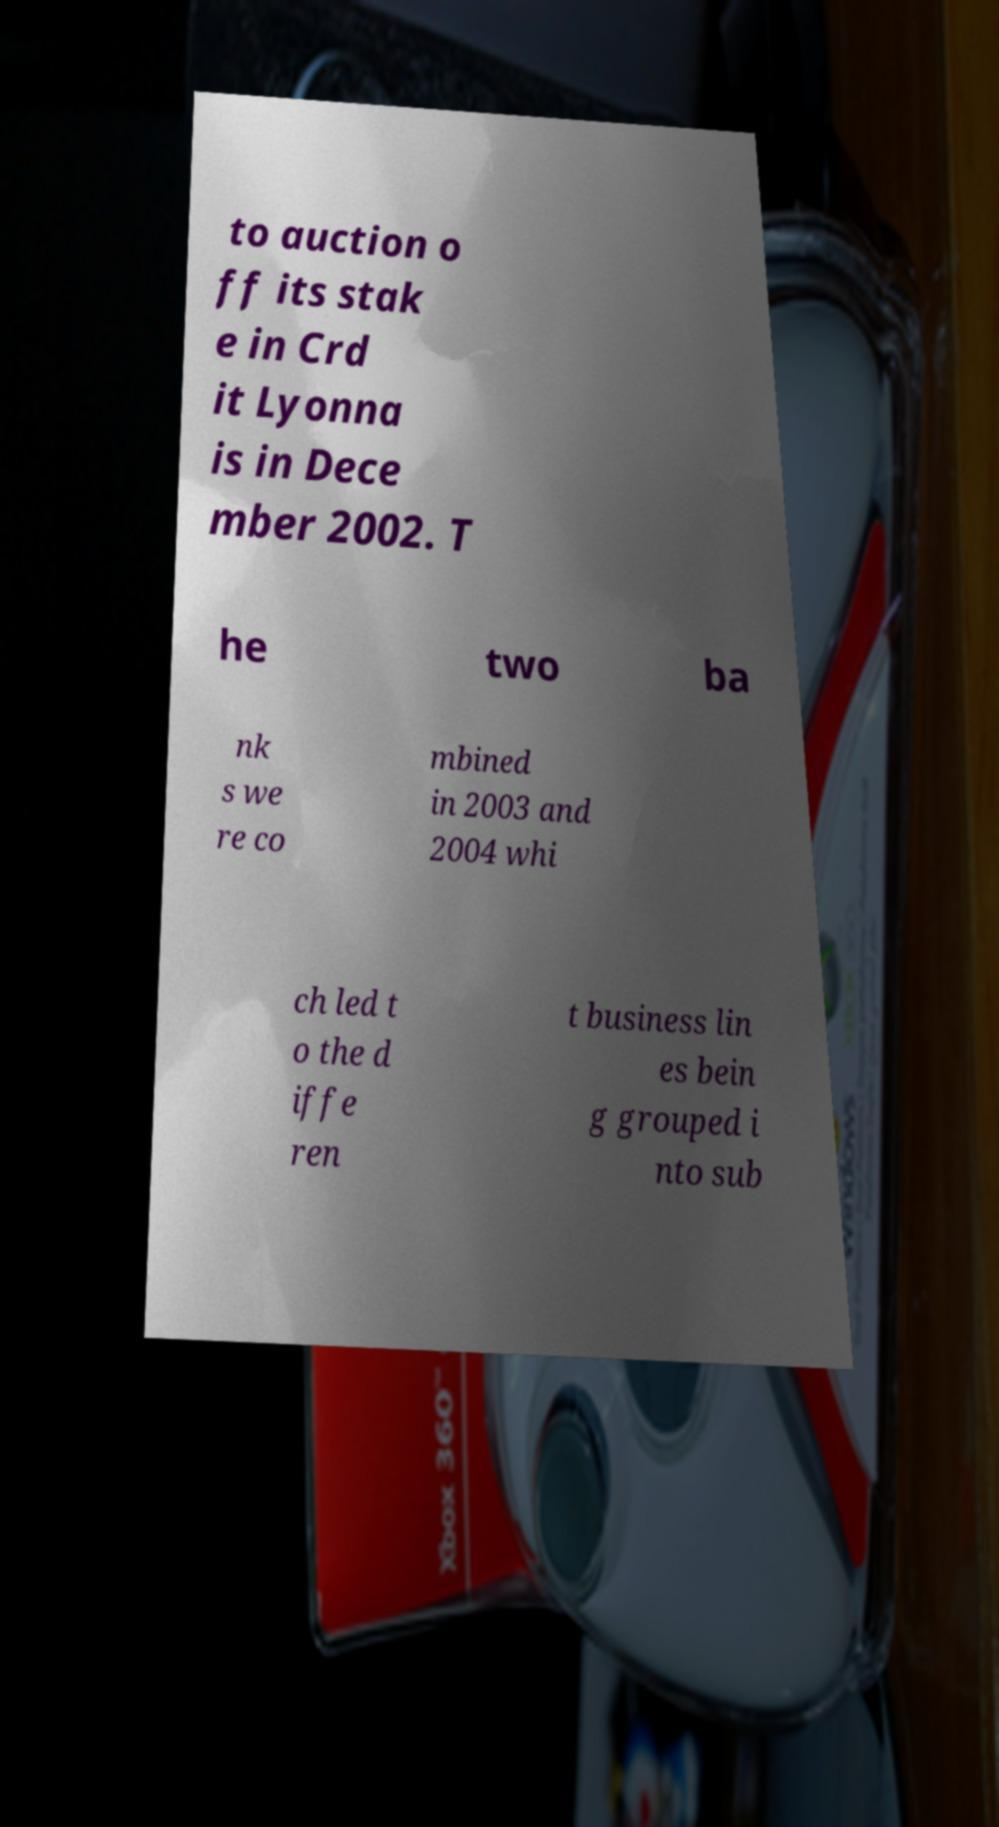Could you assist in decoding the text presented in this image and type it out clearly? to auction o ff its stak e in Crd it Lyonna is in Dece mber 2002. T he two ba nk s we re co mbined in 2003 and 2004 whi ch led t o the d iffe ren t business lin es bein g grouped i nto sub 